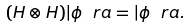<formula> <loc_0><loc_0><loc_500><loc_500>( H \otimes H ) | \phi \ r a = | \phi \ r a .</formula> 